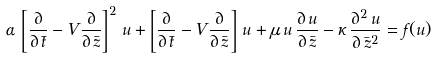Convert formula to latex. <formula><loc_0><loc_0><loc_500><loc_500>\alpha \, \left [ \frac { \partial } { \partial \, \bar { t } } - V \frac { \partial } { \partial \, \bar { z } } \right ] ^ { 2 } \, u + \left [ \frac { \partial } { \partial \, \bar { t } } - V \frac { \partial } { \partial \, \bar { z } } \right ] \, u + \mu \, u \, \frac { \partial \, u } { \partial \, \bar { z } } - \kappa \, \frac { \partial ^ { 2 } \, u } { \partial \, \bar { z } ^ { 2 } } = f ( u )</formula> 